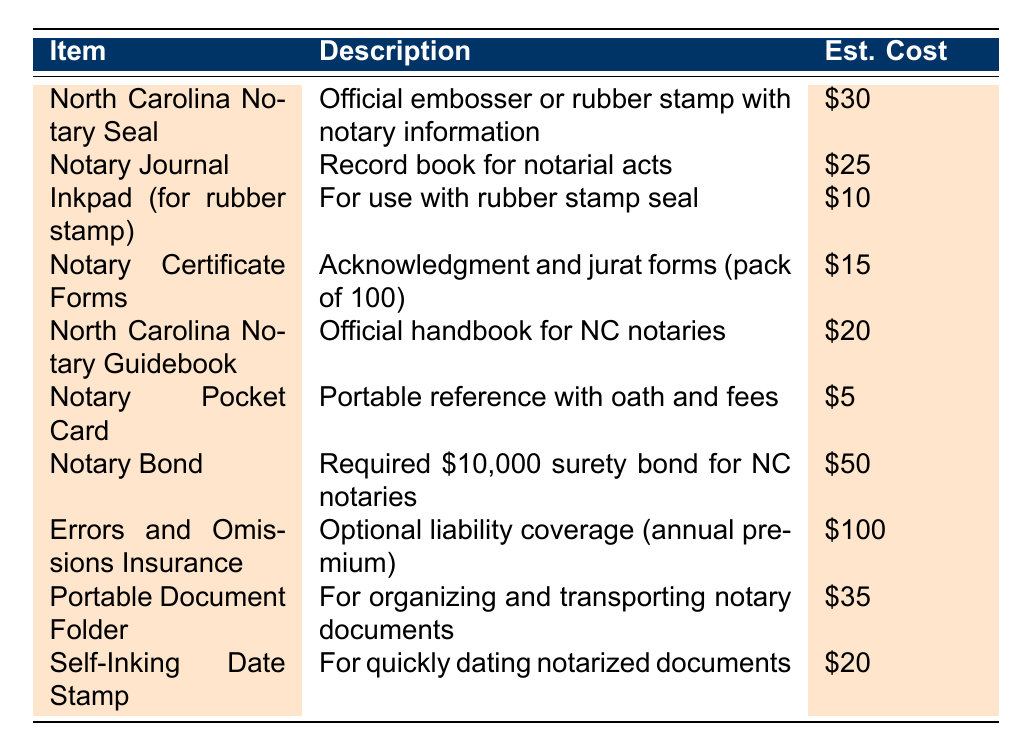What is the estimated cost of the North Carolina Notary Seal? The estimated cost for the North Carolina Notary Seal is clearly listed in the table as $30.
Answer: $30 How much do Notary Certificate Forms cost? The table specifies that Notary Certificate Forms, which include acknowledgment and jurat forms, have an estimated cost of $15.
Answer: $15 Is the Notary Pocket Card the least expensive item on the list? Yes, the Notary Pocket Card is priced at $5, which is lower than all other listed items.
Answer: Yes What is the total estimated cost for all the items combined? Adding up all the estimated costs from the table: $30 + $25 + $10 + $15 + $20 + $5 + $50 + $100 + $35 + $20 = $310.
Answer: $310 Which item has the highest estimated cost? By reviewing the table, Errors and Omissions Insurance has the highest estimated cost at $100.
Answer: $100 How much more expensive is the Notary Bond than the Notary Pocket Card? The Notary Bond costs $50, and the Notary Pocket Card costs $5. The difference is $50 - $5 = $45.
Answer: $45 What percentage of the total cost does the North Carolina Notary Guidebook represent? To find the percentage, first calculate the total cost as $310. The cost of the Guidebook is $20. The percentage is (20/310) * 100 ≈ 6.45%.
Answer: 6.45% Are there any items that cost less than $10? According to the table, only the Notary Pocket Card, which costs $5, is under $10.
Answer: Yes What is the average cost of the supplies listed in the table? There are 10 items total. The sum of costs is $310. The average cost is $310/10 = $31.
Answer: $31 How many items on the list have an estimated cost greater than $30? The items with a cost greater than $30 are the Notary Bond ($50) and Errors and Omissions Insurance ($100), totaling 2 items.
Answer: 2 